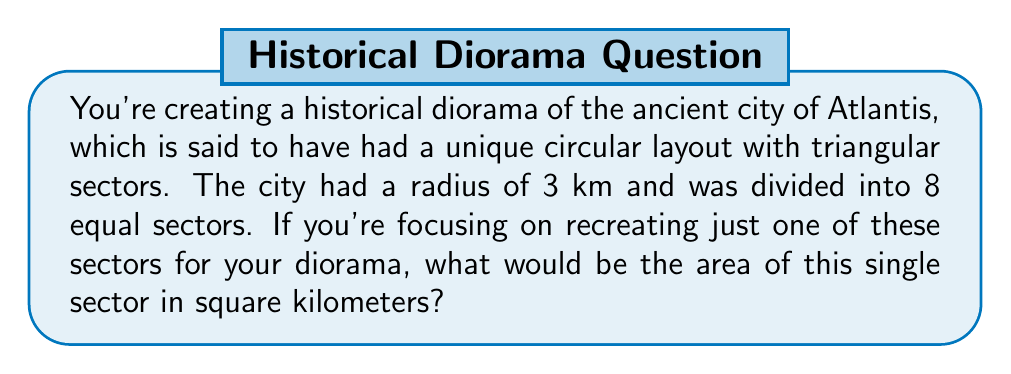Can you answer this question? Let's approach this step-by-step:

1) The city is circular with 8 equal sectors, so each sector is a triangle with its apex at the center of the circle.

2) The area of a circle is given by the formula:
   $$A_{circle} = \pi r^2$$

3) With a radius of 3 km, the total area of the city would be:
   $$A_{circle} = \pi (3)^2 = 9\pi \text{ km}^2$$

4) Since we want just one sector out of 8, we need to divide this by 8:
   $$A_{sector} = \frac{9\pi}{8} \text{ km}^2$$

5) We can simplify this further:
   $$A_{sector} = \frac{9\pi}{8} = \frac{9}{8}\pi \approx 3.5343 \text{ km}^2$$

[asy]
import geometry;

size(200);
pair O = (0,0);
real r = 3;
path c = circle(O, r);
draw(c);
for(int i=0; i<8; ++i) {
  draw(O--dir(45*i)*r);
}
label("3 km", (1.5,0), E);
fill(sector(c, 0, 45), rgb(0.8,0.8,1));
label("Area?", (1,1), NE);
[/asy]
Answer: $\frac{9}{8}\pi \text{ km}^2$ 